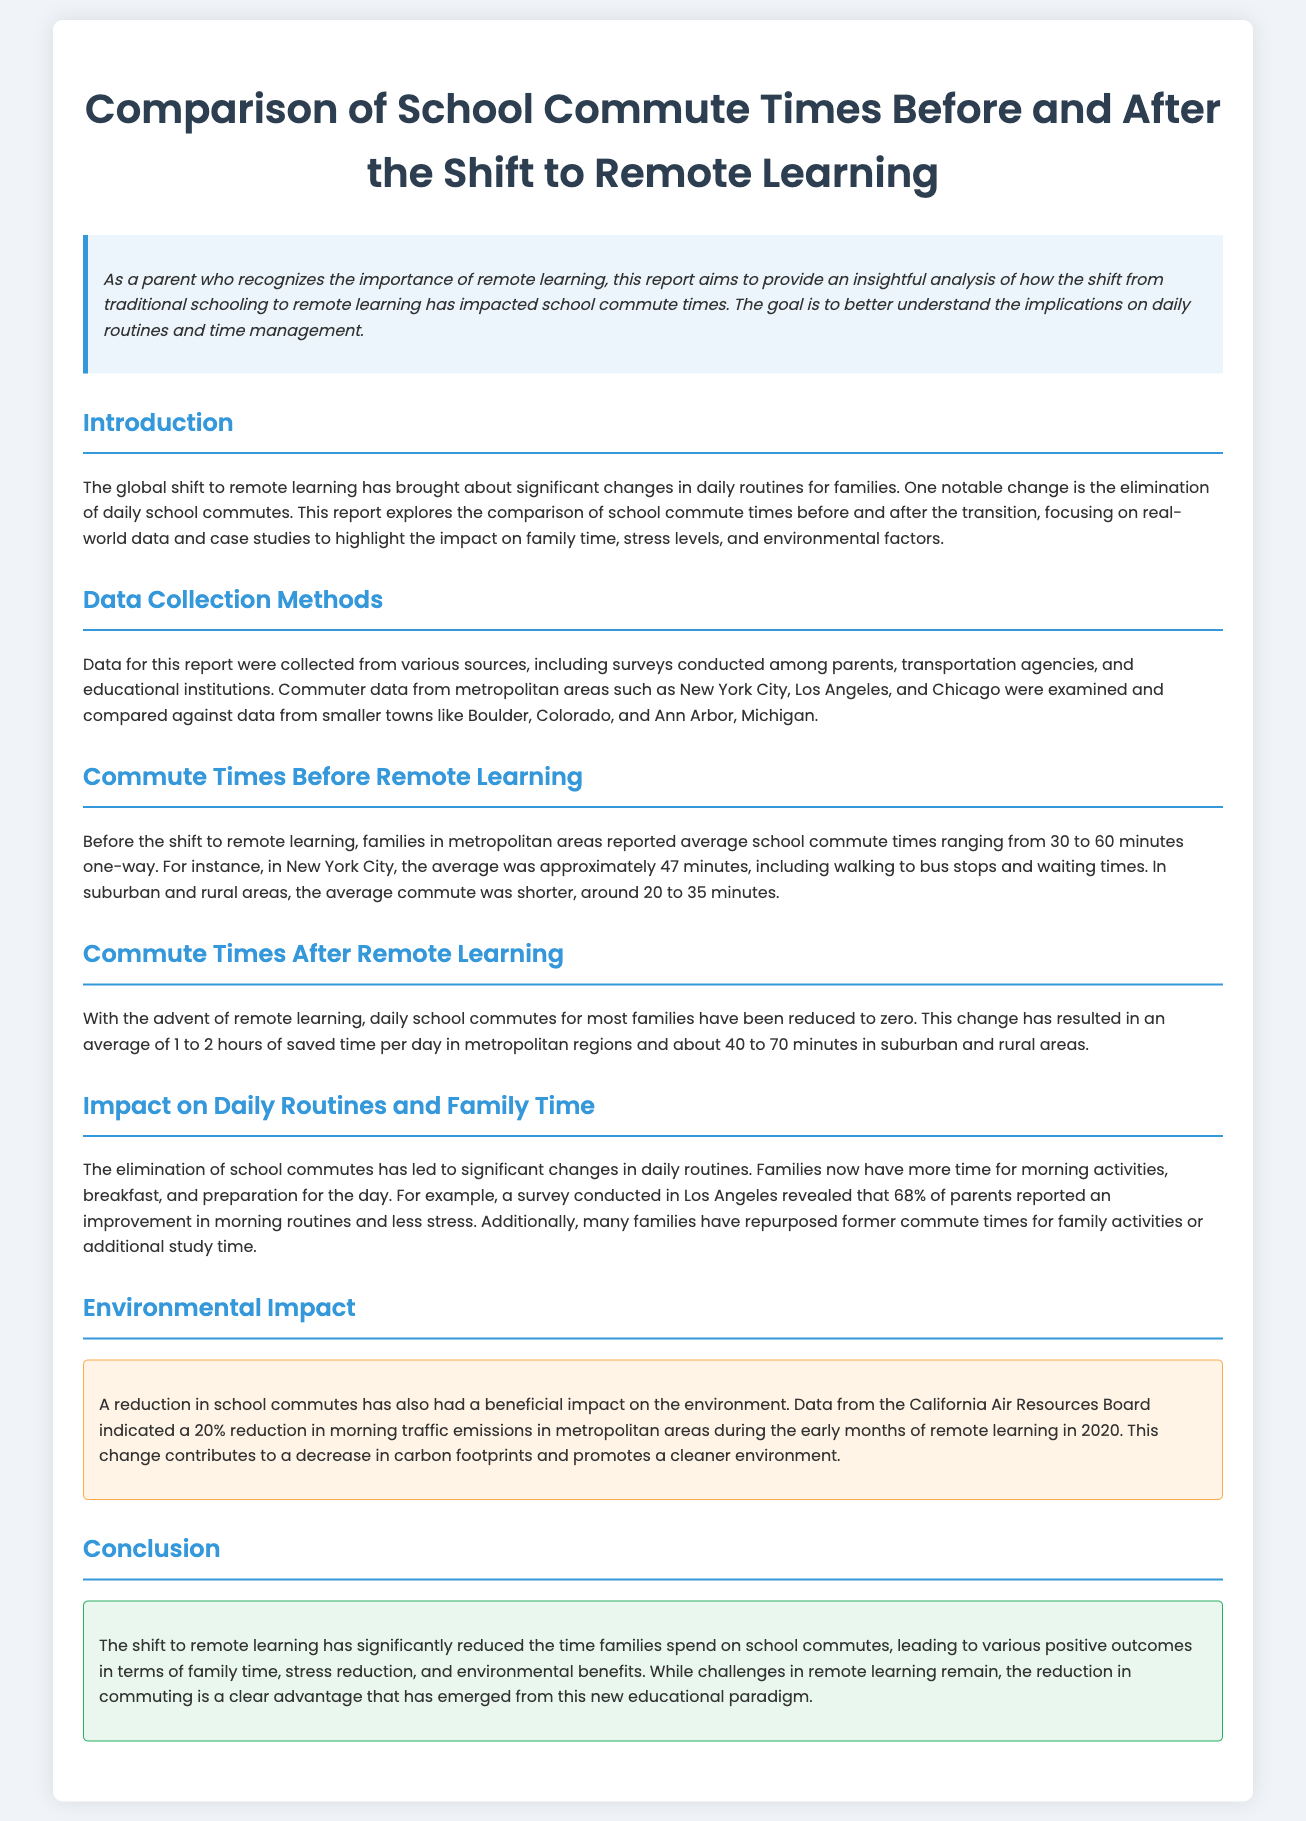What was the average school commute time in New York City before remote learning? The average school commute time in New York City before remote learning was approximately 47 minutes.
Answer: 47 minutes How much time do families save on average in metropolitan areas after the shift to remote learning? Families save an average of 1 to 2 hours of time per day in metropolitan regions after the shift to remote learning.
Answer: 1 to 2 hours What percentage of parents reported an improvement in morning routines in Los Angeles? A survey conducted in Los Angeles revealed that 68% of parents reported an improvement in morning routines.
Answer: 68% What is the reported environmental impact of the reduction in school commutes? The reduction in school commutes contributed to a 20% reduction in morning traffic emissions in metropolitan areas.
Answer: 20% What change occurred in average school commute times for suburban and rural areas after remote learning? In suburban and rural areas, the average commute time was reduced to about 40 to 70 minutes.
Answer: 40 to 70 minutes What is the overall conclusion about the impact of remote learning on family time? The conclusion indicates that the shift has led to various positive outcomes in terms of family time.
Answer: Positive outcomes in family time 